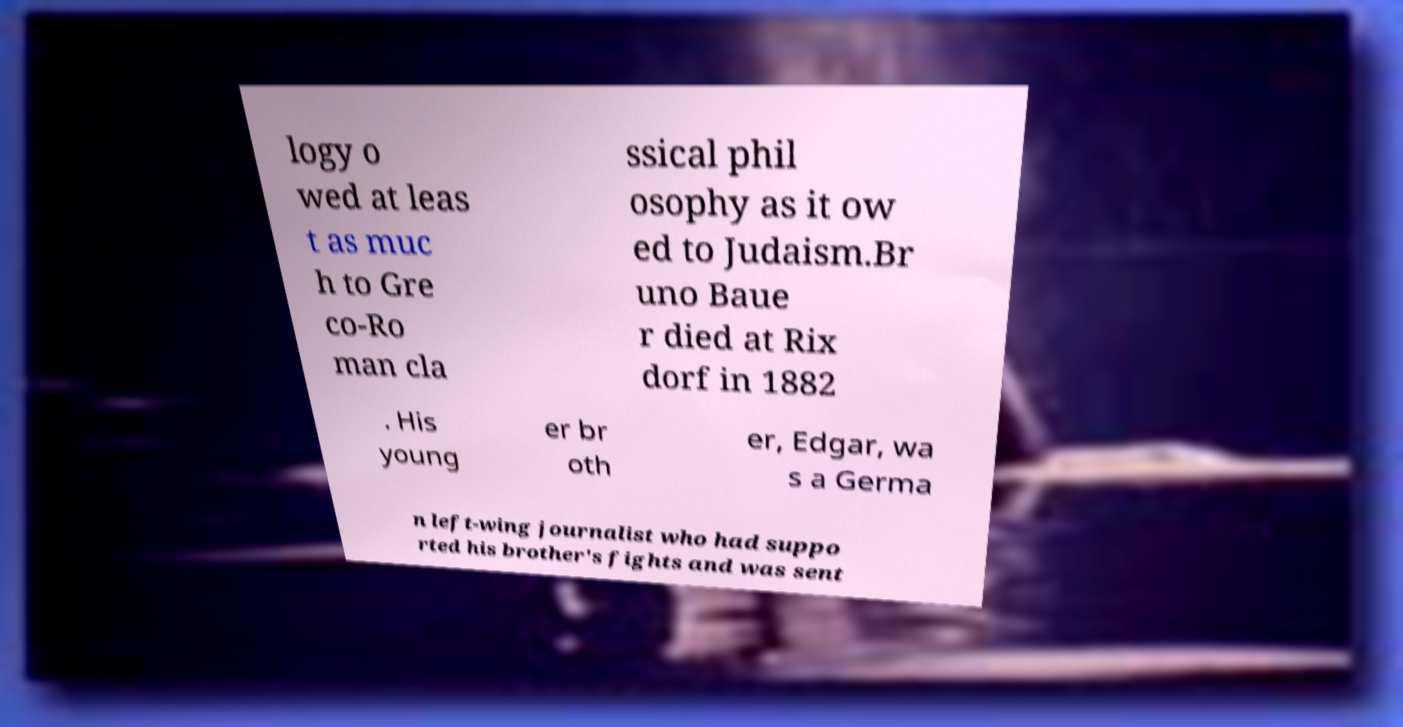Can you read and provide the text displayed in the image?This photo seems to have some interesting text. Can you extract and type it out for me? logy o wed at leas t as muc h to Gre co-Ro man cla ssical phil osophy as it ow ed to Judaism.Br uno Baue r died at Rix dorf in 1882 . His young er br oth er, Edgar, wa s a Germa n left-wing journalist who had suppo rted his brother's fights and was sent 